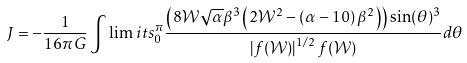Convert formula to latex. <formula><loc_0><loc_0><loc_500><loc_500>J = - \frac { 1 } { 1 6 \pi G } \int \lim i t s _ { 0 } ^ { \pi } \frac { \left ( 8 \mathcal { W } \sqrt { \alpha } \beta ^ { 3 } \left ( 2 \mathcal { W } ^ { 2 } - \left ( \alpha - 1 0 \right ) \beta ^ { 2 } \right ) \right ) \sin ( \theta ) ^ { 3 } } { \left | f ( \mathcal { W } ) \right | ^ { 1 / 2 } f ( \mathcal { W } ) } d \theta</formula> 